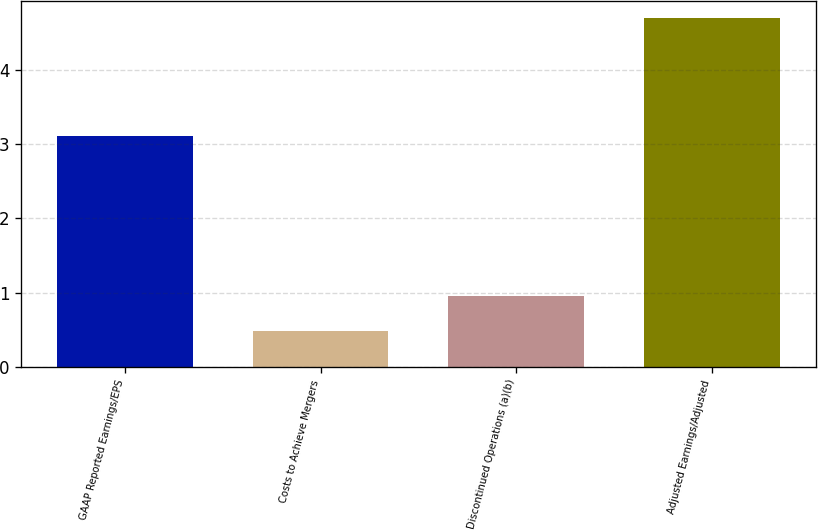<chart> <loc_0><loc_0><loc_500><loc_500><bar_chart><fcel>GAAP Reported Earnings/EPS<fcel>Costs to Achieve Mergers<fcel>Discontinued Operations (a)(b)<fcel>Adjusted Earnings/Adjusted<nl><fcel>3.11<fcel>0.48<fcel>0.95<fcel>4.69<nl></chart> 